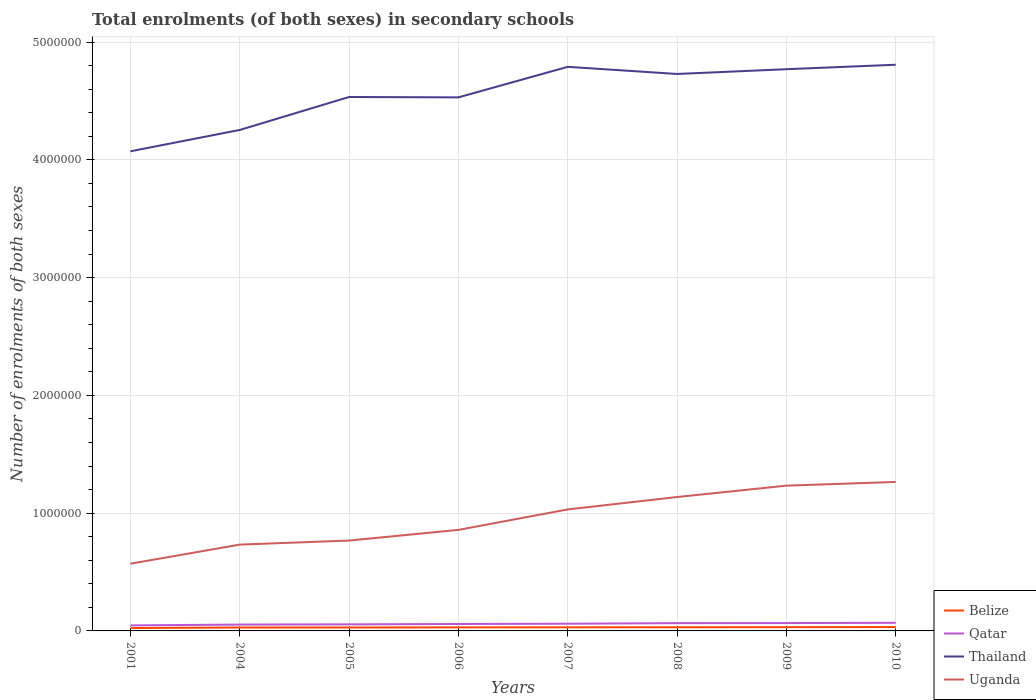Does the line corresponding to Uganda intersect with the line corresponding to Qatar?
Give a very brief answer. No. Is the number of lines equal to the number of legend labels?
Provide a short and direct response. Yes. Across all years, what is the maximum number of enrolments in secondary schools in Qatar?
Keep it short and to the point. 4.69e+04. In which year was the number of enrolments in secondary schools in Uganda maximum?
Your response must be concise. 2001. What is the total number of enrolments in secondary schools in Uganda in the graph?
Make the answer very short. -4.98e+05. What is the difference between the highest and the second highest number of enrolments in secondary schools in Belize?
Provide a short and direct response. 8385. What is the difference between the highest and the lowest number of enrolments in secondary schools in Uganda?
Your answer should be compact. 4. Is the number of enrolments in secondary schools in Belize strictly greater than the number of enrolments in secondary schools in Qatar over the years?
Provide a succinct answer. Yes. How many lines are there?
Keep it short and to the point. 4. How many legend labels are there?
Give a very brief answer. 4. How are the legend labels stacked?
Provide a short and direct response. Vertical. What is the title of the graph?
Give a very brief answer. Total enrolments (of both sexes) in secondary schools. Does "Serbia" appear as one of the legend labels in the graph?
Offer a terse response. No. What is the label or title of the Y-axis?
Ensure brevity in your answer.  Number of enrolments of both sexes. What is the Number of enrolments of both sexes in Belize in 2001?
Make the answer very short. 2.44e+04. What is the Number of enrolments of both sexes in Qatar in 2001?
Offer a terse response. 4.69e+04. What is the Number of enrolments of both sexes of Thailand in 2001?
Offer a very short reply. 4.07e+06. What is the Number of enrolments of both sexes of Uganda in 2001?
Make the answer very short. 5.71e+05. What is the Number of enrolments of both sexes in Belize in 2004?
Keep it short and to the point. 2.91e+04. What is the Number of enrolments of both sexes in Qatar in 2004?
Your answer should be very brief. 5.40e+04. What is the Number of enrolments of both sexes of Thailand in 2004?
Provide a short and direct response. 4.25e+06. What is the Number of enrolments of both sexes in Uganda in 2004?
Your answer should be very brief. 7.33e+05. What is the Number of enrolments of both sexes in Belize in 2005?
Make the answer very short. 2.92e+04. What is the Number of enrolments of both sexes in Qatar in 2005?
Ensure brevity in your answer.  5.57e+04. What is the Number of enrolments of both sexes in Thailand in 2005?
Your response must be concise. 4.53e+06. What is the Number of enrolments of both sexes of Uganda in 2005?
Offer a very short reply. 7.67e+05. What is the Number of enrolments of both sexes in Belize in 2006?
Ensure brevity in your answer.  3.01e+04. What is the Number of enrolments of both sexes in Qatar in 2006?
Offer a terse response. 5.88e+04. What is the Number of enrolments of both sexes in Thailand in 2006?
Your answer should be very brief. 4.53e+06. What is the Number of enrolments of both sexes of Uganda in 2006?
Ensure brevity in your answer.  8.58e+05. What is the Number of enrolments of both sexes in Belize in 2007?
Offer a very short reply. 3.05e+04. What is the Number of enrolments of both sexes in Qatar in 2007?
Provide a short and direct response. 6.11e+04. What is the Number of enrolments of both sexes of Thailand in 2007?
Make the answer very short. 4.79e+06. What is the Number of enrolments of both sexes of Uganda in 2007?
Offer a terse response. 1.03e+06. What is the Number of enrolments of both sexes in Belize in 2008?
Ensure brevity in your answer.  3.11e+04. What is the Number of enrolments of both sexes of Qatar in 2008?
Keep it short and to the point. 6.61e+04. What is the Number of enrolments of both sexes in Thailand in 2008?
Provide a succinct answer. 4.73e+06. What is the Number of enrolments of both sexes of Uganda in 2008?
Your answer should be very brief. 1.14e+06. What is the Number of enrolments of both sexes in Belize in 2009?
Offer a terse response. 3.17e+04. What is the Number of enrolments of both sexes of Qatar in 2009?
Your answer should be compact. 6.66e+04. What is the Number of enrolments of both sexes of Thailand in 2009?
Keep it short and to the point. 4.77e+06. What is the Number of enrolments of both sexes in Uganda in 2009?
Offer a very short reply. 1.23e+06. What is the Number of enrolments of both sexes in Belize in 2010?
Make the answer very short. 3.28e+04. What is the Number of enrolments of both sexes of Qatar in 2010?
Give a very brief answer. 6.89e+04. What is the Number of enrolments of both sexes in Thailand in 2010?
Your answer should be compact. 4.81e+06. What is the Number of enrolments of both sexes in Uganda in 2010?
Provide a succinct answer. 1.26e+06. Across all years, what is the maximum Number of enrolments of both sexes of Belize?
Provide a short and direct response. 3.28e+04. Across all years, what is the maximum Number of enrolments of both sexes in Qatar?
Your answer should be compact. 6.89e+04. Across all years, what is the maximum Number of enrolments of both sexes of Thailand?
Your answer should be compact. 4.81e+06. Across all years, what is the maximum Number of enrolments of both sexes in Uganda?
Your answer should be very brief. 1.26e+06. Across all years, what is the minimum Number of enrolments of both sexes of Belize?
Your answer should be compact. 2.44e+04. Across all years, what is the minimum Number of enrolments of both sexes in Qatar?
Your response must be concise. 4.69e+04. Across all years, what is the minimum Number of enrolments of both sexes in Thailand?
Offer a very short reply. 4.07e+06. Across all years, what is the minimum Number of enrolments of both sexes of Uganda?
Make the answer very short. 5.71e+05. What is the total Number of enrolments of both sexes in Belize in the graph?
Keep it short and to the point. 2.39e+05. What is the total Number of enrolments of both sexes of Qatar in the graph?
Keep it short and to the point. 4.78e+05. What is the total Number of enrolments of both sexes in Thailand in the graph?
Offer a terse response. 3.65e+07. What is the total Number of enrolments of both sexes in Uganda in the graph?
Keep it short and to the point. 7.60e+06. What is the difference between the Number of enrolments of both sexes of Belize in 2001 and that in 2004?
Your answer should be very brief. -4687. What is the difference between the Number of enrolments of both sexes in Qatar in 2001 and that in 2004?
Give a very brief answer. -7022. What is the difference between the Number of enrolments of both sexes of Thailand in 2001 and that in 2004?
Make the answer very short. -1.81e+05. What is the difference between the Number of enrolments of both sexes in Uganda in 2001 and that in 2004?
Ensure brevity in your answer.  -1.62e+05. What is the difference between the Number of enrolments of both sexes in Belize in 2001 and that in 2005?
Provide a succinct answer. -4790. What is the difference between the Number of enrolments of both sexes of Qatar in 2001 and that in 2005?
Your response must be concise. -8774. What is the difference between the Number of enrolments of both sexes of Thailand in 2001 and that in 2005?
Your answer should be compact. -4.61e+05. What is the difference between the Number of enrolments of both sexes in Uganda in 2001 and that in 2005?
Provide a succinct answer. -1.97e+05. What is the difference between the Number of enrolments of both sexes of Belize in 2001 and that in 2006?
Offer a terse response. -5689. What is the difference between the Number of enrolments of both sexes of Qatar in 2001 and that in 2006?
Keep it short and to the point. -1.19e+04. What is the difference between the Number of enrolments of both sexes of Thailand in 2001 and that in 2006?
Keep it short and to the point. -4.58e+05. What is the difference between the Number of enrolments of both sexes of Uganda in 2001 and that in 2006?
Ensure brevity in your answer.  -2.87e+05. What is the difference between the Number of enrolments of both sexes in Belize in 2001 and that in 2007?
Your answer should be compact. -6080. What is the difference between the Number of enrolments of both sexes of Qatar in 2001 and that in 2007?
Ensure brevity in your answer.  -1.42e+04. What is the difference between the Number of enrolments of both sexes in Thailand in 2001 and that in 2007?
Offer a very short reply. -7.17e+05. What is the difference between the Number of enrolments of both sexes of Uganda in 2001 and that in 2007?
Offer a very short reply. -4.61e+05. What is the difference between the Number of enrolments of both sexes of Belize in 2001 and that in 2008?
Provide a succinct answer. -6725. What is the difference between the Number of enrolments of both sexes in Qatar in 2001 and that in 2008?
Provide a succinct answer. -1.92e+04. What is the difference between the Number of enrolments of both sexes of Thailand in 2001 and that in 2008?
Provide a short and direct response. -6.57e+05. What is the difference between the Number of enrolments of both sexes in Uganda in 2001 and that in 2008?
Ensure brevity in your answer.  -5.66e+05. What is the difference between the Number of enrolments of both sexes in Belize in 2001 and that in 2009?
Give a very brief answer. -7326. What is the difference between the Number of enrolments of both sexes in Qatar in 2001 and that in 2009?
Your answer should be very brief. -1.97e+04. What is the difference between the Number of enrolments of both sexes of Thailand in 2001 and that in 2009?
Your answer should be very brief. -6.97e+05. What is the difference between the Number of enrolments of both sexes of Uganda in 2001 and that in 2009?
Your answer should be compact. -6.63e+05. What is the difference between the Number of enrolments of both sexes in Belize in 2001 and that in 2010?
Ensure brevity in your answer.  -8385. What is the difference between the Number of enrolments of both sexes of Qatar in 2001 and that in 2010?
Your answer should be very brief. -2.20e+04. What is the difference between the Number of enrolments of both sexes in Thailand in 2001 and that in 2010?
Your answer should be very brief. -7.35e+05. What is the difference between the Number of enrolments of both sexes of Uganda in 2001 and that in 2010?
Offer a terse response. -6.94e+05. What is the difference between the Number of enrolments of both sexes in Belize in 2004 and that in 2005?
Your answer should be very brief. -103. What is the difference between the Number of enrolments of both sexes of Qatar in 2004 and that in 2005?
Offer a terse response. -1752. What is the difference between the Number of enrolments of both sexes in Thailand in 2004 and that in 2005?
Offer a very short reply. -2.80e+05. What is the difference between the Number of enrolments of both sexes of Uganda in 2004 and that in 2005?
Your answer should be compact. -3.45e+04. What is the difference between the Number of enrolments of both sexes of Belize in 2004 and that in 2006?
Your answer should be compact. -1002. What is the difference between the Number of enrolments of both sexes in Qatar in 2004 and that in 2006?
Make the answer very short. -4834. What is the difference between the Number of enrolments of both sexes of Thailand in 2004 and that in 2006?
Your response must be concise. -2.77e+05. What is the difference between the Number of enrolments of both sexes in Uganda in 2004 and that in 2006?
Give a very brief answer. -1.25e+05. What is the difference between the Number of enrolments of both sexes in Belize in 2004 and that in 2007?
Give a very brief answer. -1393. What is the difference between the Number of enrolments of both sexes of Qatar in 2004 and that in 2007?
Give a very brief answer. -7157. What is the difference between the Number of enrolments of both sexes of Thailand in 2004 and that in 2007?
Your answer should be compact. -5.36e+05. What is the difference between the Number of enrolments of both sexes in Uganda in 2004 and that in 2007?
Offer a very short reply. -2.99e+05. What is the difference between the Number of enrolments of both sexes of Belize in 2004 and that in 2008?
Your answer should be compact. -2038. What is the difference between the Number of enrolments of both sexes in Qatar in 2004 and that in 2008?
Give a very brief answer. -1.21e+04. What is the difference between the Number of enrolments of both sexes of Thailand in 2004 and that in 2008?
Your answer should be compact. -4.75e+05. What is the difference between the Number of enrolments of both sexes of Uganda in 2004 and that in 2008?
Provide a succinct answer. -4.04e+05. What is the difference between the Number of enrolments of both sexes of Belize in 2004 and that in 2009?
Give a very brief answer. -2639. What is the difference between the Number of enrolments of both sexes of Qatar in 2004 and that in 2009?
Provide a short and direct response. -1.26e+04. What is the difference between the Number of enrolments of both sexes in Thailand in 2004 and that in 2009?
Offer a terse response. -5.16e+05. What is the difference between the Number of enrolments of both sexes of Uganda in 2004 and that in 2009?
Provide a succinct answer. -5.01e+05. What is the difference between the Number of enrolments of both sexes of Belize in 2004 and that in 2010?
Offer a very short reply. -3698. What is the difference between the Number of enrolments of both sexes in Qatar in 2004 and that in 2010?
Ensure brevity in your answer.  -1.50e+04. What is the difference between the Number of enrolments of both sexes of Thailand in 2004 and that in 2010?
Make the answer very short. -5.54e+05. What is the difference between the Number of enrolments of both sexes in Uganda in 2004 and that in 2010?
Your response must be concise. -5.32e+05. What is the difference between the Number of enrolments of both sexes of Belize in 2005 and that in 2006?
Your response must be concise. -899. What is the difference between the Number of enrolments of both sexes in Qatar in 2005 and that in 2006?
Provide a succinct answer. -3082. What is the difference between the Number of enrolments of both sexes in Thailand in 2005 and that in 2006?
Provide a succinct answer. 3144. What is the difference between the Number of enrolments of both sexes of Uganda in 2005 and that in 2006?
Provide a short and direct response. -9.05e+04. What is the difference between the Number of enrolments of both sexes in Belize in 2005 and that in 2007?
Offer a terse response. -1290. What is the difference between the Number of enrolments of both sexes in Qatar in 2005 and that in 2007?
Provide a short and direct response. -5405. What is the difference between the Number of enrolments of both sexes of Thailand in 2005 and that in 2007?
Your response must be concise. -2.56e+05. What is the difference between the Number of enrolments of both sexes of Uganda in 2005 and that in 2007?
Provide a short and direct response. -2.64e+05. What is the difference between the Number of enrolments of both sexes of Belize in 2005 and that in 2008?
Your response must be concise. -1935. What is the difference between the Number of enrolments of both sexes in Qatar in 2005 and that in 2008?
Your response must be concise. -1.04e+04. What is the difference between the Number of enrolments of both sexes in Thailand in 2005 and that in 2008?
Keep it short and to the point. -1.96e+05. What is the difference between the Number of enrolments of both sexes of Uganda in 2005 and that in 2008?
Your response must be concise. -3.70e+05. What is the difference between the Number of enrolments of both sexes in Belize in 2005 and that in 2009?
Provide a succinct answer. -2536. What is the difference between the Number of enrolments of both sexes in Qatar in 2005 and that in 2009?
Make the answer very short. -1.09e+04. What is the difference between the Number of enrolments of both sexes of Thailand in 2005 and that in 2009?
Keep it short and to the point. -2.36e+05. What is the difference between the Number of enrolments of both sexes of Uganda in 2005 and that in 2009?
Your answer should be compact. -4.66e+05. What is the difference between the Number of enrolments of both sexes of Belize in 2005 and that in 2010?
Your response must be concise. -3595. What is the difference between the Number of enrolments of both sexes of Qatar in 2005 and that in 2010?
Offer a terse response. -1.32e+04. What is the difference between the Number of enrolments of both sexes in Thailand in 2005 and that in 2010?
Provide a short and direct response. -2.74e+05. What is the difference between the Number of enrolments of both sexes in Uganda in 2005 and that in 2010?
Your response must be concise. -4.98e+05. What is the difference between the Number of enrolments of both sexes of Belize in 2006 and that in 2007?
Provide a short and direct response. -391. What is the difference between the Number of enrolments of both sexes of Qatar in 2006 and that in 2007?
Provide a short and direct response. -2323. What is the difference between the Number of enrolments of both sexes of Thailand in 2006 and that in 2007?
Offer a very short reply. -2.59e+05. What is the difference between the Number of enrolments of both sexes in Uganda in 2006 and that in 2007?
Provide a short and direct response. -1.74e+05. What is the difference between the Number of enrolments of both sexes in Belize in 2006 and that in 2008?
Provide a succinct answer. -1036. What is the difference between the Number of enrolments of both sexes in Qatar in 2006 and that in 2008?
Your response must be concise. -7297. What is the difference between the Number of enrolments of both sexes in Thailand in 2006 and that in 2008?
Offer a terse response. -1.99e+05. What is the difference between the Number of enrolments of both sexes in Uganda in 2006 and that in 2008?
Give a very brief answer. -2.79e+05. What is the difference between the Number of enrolments of both sexes in Belize in 2006 and that in 2009?
Make the answer very short. -1637. What is the difference between the Number of enrolments of both sexes in Qatar in 2006 and that in 2009?
Give a very brief answer. -7797. What is the difference between the Number of enrolments of both sexes of Thailand in 2006 and that in 2009?
Your response must be concise. -2.39e+05. What is the difference between the Number of enrolments of both sexes of Uganda in 2006 and that in 2009?
Keep it short and to the point. -3.76e+05. What is the difference between the Number of enrolments of both sexes of Belize in 2006 and that in 2010?
Your response must be concise. -2696. What is the difference between the Number of enrolments of both sexes of Qatar in 2006 and that in 2010?
Give a very brief answer. -1.01e+04. What is the difference between the Number of enrolments of both sexes in Thailand in 2006 and that in 2010?
Keep it short and to the point. -2.77e+05. What is the difference between the Number of enrolments of both sexes in Uganda in 2006 and that in 2010?
Your answer should be very brief. -4.07e+05. What is the difference between the Number of enrolments of both sexes in Belize in 2007 and that in 2008?
Give a very brief answer. -645. What is the difference between the Number of enrolments of both sexes of Qatar in 2007 and that in 2008?
Provide a succinct answer. -4974. What is the difference between the Number of enrolments of both sexes in Thailand in 2007 and that in 2008?
Your response must be concise. 6.06e+04. What is the difference between the Number of enrolments of both sexes of Uganda in 2007 and that in 2008?
Provide a succinct answer. -1.05e+05. What is the difference between the Number of enrolments of both sexes of Belize in 2007 and that in 2009?
Make the answer very short. -1246. What is the difference between the Number of enrolments of both sexes of Qatar in 2007 and that in 2009?
Keep it short and to the point. -5474. What is the difference between the Number of enrolments of both sexes of Thailand in 2007 and that in 2009?
Your response must be concise. 2.01e+04. What is the difference between the Number of enrolments of both sexes of Uganda in 2007 and that in 2009?
Your response must be concise. -2.02e+05. What is the difference between the Number of enrolments of both sexes of Belize in 2007 and that in 2010?
Your answer should be very brief. -2305. What is the difference between the Number of enrolments of both sexes of Qatar in 2007 and that in 2010?
Provide a short and direct response. -7814. What is the difference between the Number of enrolments of both sexes in Thailand in 2007 and that in 2010?
Offer a terse response. -1.78e+04. What is the difference between the Number of enrolments of both sexes of Uganda in 2007 and that in 2010?
Ensure brevity in your answer.  -2.33e+05. What is the difference between the Number of enrolments of both sexes of Belize in 2008 and that in 2009?
Provide a short and direct response. -601. What is the difference between the Number of enrolments of both sexes of Qatar in 2008 and that in 2009?
Ensure brevity in your answer.  -500. What is the difference between the Number of enrolments of both sexes in Thailand in 2008 and that in 2009?
Provide a succinct answer. -4.04e+04. What is the difference between the Number of enrolments of both sexes in Uganda in 2008 and that in 2009?
Offer a terse response. -9.66e+04. What is the difference between the Number of enrolments of both sexes of Belize in 2008 and that in 2010?
Offer a terse response. -1660. What is the difference between the Number of enrolments of both sexes in Qatar in 2008 and that in 2010?
Provide a succinct answer. -2840. What is the difference between the Number of enrolments of both sexes of Thailand in 2008 and that in 2010?
Make the answer very short. -7.83e+04. What is the difference between the Number of enrolments of both sexes of Uganda in 2008 and that in 2010?
Give a very brief answer. -1.28e+05. What is the difference between the Number of enrolments of both sexes in Belize in 2009 and that in 2010?
Offer a very short reply. -1059. What is the difference between the Number of enrolments of both sexes of Qatar in 2009 and that in 2010?
Provide a succinct answer. -2340. What is the difference between the Number of enrolments of both sexes in Thailand in 2009 and that in 2010?
Provide a short and direct response. -3.79e+04. What is the difference between the Number of enrolments of both sexes in Uganda in 2009 and that in 2010?
Make the answer very short. -3.16e+04. What is the difference between the Number of enrolments of both sexes in Belize in 2001 and the Number of enrolments of both sexes in Qatar in 2004?
Provide a short and direct response. -2.96e+04. What is the difference between the Number of enrolments of both sexes of Belize in 2001 and the Number of enrolments of both sexes of Thailand in 2004?
Provide a succinct answer. -4.23e+06. What is the difference between the Number of enrolments of both sexes in Belize in 2001 and the Number of enrolments of both sexes in Uganda in 2004?
Provide a short and direct response. -7.08e+05. What is the difference between the Number of enrolments of both sexes in Qatar in 2001 and the Number of enrolments of both sexes in Thailand in 2004?
Your response must be concise. -4.21e+06. What is the difference between the Number of enrolments of both sexes of Qatar in 2001 and the Number of enrolments of both sexes of Uganda in 2004?
Give a very brief answer. -6.86e+05. What is the difference between the Number of enrolments of both sexes in Thailand in 2001 and the Number of enrolments of both sexes in Uganda in 2004?
Your answer should be very brief. 3.34e+06. What is the difference between the Number of enrolments of both sexes in Belize in 2001 and the Number of enrolments of both sexes in Qatar in 2005?
Give a very brief answer. -3.13e+04. What is the difference between the Number of enrolments of both sexes of Belize in 2001 and the Number of enrolments of both sexes of Thailand in 2005?
Provide a short and direct response. -4.51e+06. What is the difference between the Number of enrolments of both sexes of Belize in 2001 and the Number of enrolments of both sexes of Uganda in 2005?
Your answer should be compact. -7.43e+05. What is the difference between the Number of enrolments of both sexes of Qatar in 2001 and the Number of enrolments of both sexes of Thailand in 2005?
Ensure brevity in your answer.  -4.49e+06. What is the difference between the Number of enrolments of both sexes in Qatar in 2001 and the Number of enrolments of both sexes in Uganda in 2005?
Provide a short and direct response. -7.20e+05. What is the difference between the Number of enrolments of both sexes of Thailand in 2001 and the Number of enrolments of both sexes of Uganda in 2005?
Provide a succinct answer. 3.30e+06. What is the difference between the Number of enrolments of both sexes in Belize in 2001 and the Number of enrolments of both sexes in Qatar in 2006?
Your answer should be compact. -3.44e+04. What is the difference between the Number of enrolments of both sexes of Belize in 2001 and the Number of enrolments of both sexes of Thailand in 2006?
Keep it short and to the point. -4.51e+06. What is the difference between the Number of enrolments of both sexes of Belize in 2001 and the Number of enrolments of both sexes of Uganda in 2006?
Give a very brief answer. -8.33e+05. What is the difference between the Number of enrolments of both sexes of Qatar in 2001 and the Number of enrolments of both sexes of Thailand in 2006?
Make the answer very short. -4.48e+06. What is the difference between the Number of enrolments of both sexes in Qatar in 2001 and the Number of enrolments of both sexes in Uganda in 2006?
Provide a short and direct response. -8.11e+05. What is the difference between the Number of enrolments of both sexes in Thailand in 2001 and the Number of enrolments of both sexes in Uganda in 2006?
Offer a terse response. 3.21e+06. What is the difference between the Number of enrolments of both sexes of Belize in 2001 and the Number of enrolments of both sexes of Qatar in 2007?
Keep it short and to the point. -3.67e+04. What is the difference between the Number of enrolments of both sexes of Belize in 2001 and the Number of enrolments of both sexes of Thailand in 2007?
Provide a succinct answer. -4.76e+06. What is the difference between the Number of enrolments of both sexes in Belize in 2001 and the Number of enrolments of both sexes in Uganda in 2007?
Give a very brief answer. -1.01e+06. What is the difference between the Number of enrolments of both sexes in Qatar in 2001 and the Number of enrolments of both sexes in Thailand in 2007?
Offer a terse response. -4.74e+06. What is the difference between the Number of enrolments of both sexes in Qatar in 2001 and the Number of enrolments of both sexes in Uganda in 2007?
Keep it short and to the point. -9.85e+05. What is the difference between the Number of enrolments of both sexes in Thailand in 2001 and the Number of enrolments of both sexes in Uganda in 2007?
Keep it short and to the point. 3.04e+06. What is the difference between the Number of enrolments of both sexes of Belize in 2001 and the Number of enrolments of both sexes of Qatar in 2008?
Offer a terse response. -4.17e+04. What is the difference between the Number of enrolments of both sexes in Belize in 2001 and the Number of enrolments of both sexes in Thailand in 2008?
Give a very brief answer. -4.70e+06. What is the difference between the Number of enrolments of both sexes of Belize in 2001 and the Number of enrolments of both sexes of Uganda in 2008?
Your answer should be compact. -1.11e+06. What is the difference between the Number of enrolments of both sexes in Qatar in 2001 and the Number of enrolments of both sexes in Thailand in 2008?
Offer a very short reply. -4.68e+06. What is the difference between the Number of enrolments of both sexes in Qatar in 2001 and the Number of enrolments of both sexes in Uganda in 2008?
Ensure brevity in your answer.  -1.09e+06. What is the difference between the Number of enrolments of both sexes of Thailand in 2001 and the Number of enrolments of both sexes of Uganda in 2008?
Provide a short and direct response. 2.94e+06. What is the difference between the Number of enrolments of both sexes of Belize in 2001 and the Number of enrolments of both sexes of Qatar in 2009?
Offer a terse response. -4.22e+04. What is the difference between the Number of enrolments of both sexes of Belize in 2001 and the Number of enrolments of both sexes of Thailand in 2009?
Give a very brief answer. -4.74e+06. What is the difference between the Number of enrolments of both sexes in Belize in 2001 and the Number of enrolments of both sexes in Uganda in 2009?
Give a very brief answer. -1.21e+06. What is the difference between the Number of enrolments of both sexes in Qatar in 2001 and the Number of enrolments of both sexes in Thailand in 2009?
Your answer should be very brief. -4.72e+06. What is the difference between the Number of enrolments of both sexes in Qatar in 2001 and the Number of enrolments of both sexes in Uganda in 2009?
Your response must be concise. -1.19e+06. What is the difference between the Number of enrolments of both sexes of Thailand in 2001 and the Number of enrolments of both sexes of Uganda in 2009?
Offer a very short reply. 2.84e+06. What is the difference between the Number of enrolments of both sexes in Belize in 2001 and the Number of enrolments of both sexes in Qatar in 2010?
Provide a short and direct response. -4.45e+04. What is the difference between the Number of enrolments of both sexes of Belize in 2001 and the Number of enrolments of both sexes of Thailand in 2010?
Give a very brief answer. -4.78e+06. What is the difference between the Number of enrolments of both sexes in Belize in 2001 and the Number of enrolments of both sexes in Uganda in 2010?
Make the answer very short. -1.24e+06. What is the difference between the Number of enrolments of both sexes of Qatar in 2001 and the Number of enrolments of both sexes of Thailand in 2010?
Make the answer very short. -4.76e+06. What is the difference between the Number of enrolments of both sexes of Qatar in 2001 and the Number of enrolments of both sexes of Uganda in 2010?
Keep it short and to the point. -1.22e+06. What is the difference between the Number of enrolments of both sexes in Thailand in 2001 and the Number of enrolments of both sexes in Uganda in 2010?
Offer a very short reply. 2.81e+06. What is the difference between the Number of enrolments of both sexes of Belize in 2004 and the Number of enrolments of both sexes of Qatar in 2005?
Keep it short and to the point. -2.66e+04. What is the difference between the Number of enrolments of both sexes in Belize in 2004 and the Number of enrolments of both sexes in Thailand in 2005?
Make the answer very short. -4.50e+06. What is the difference between the Number of enrolments of both sexes of Belize in 2004 and the Number of enrolments of both sexes of Uganda in 2005?
Make the answer very short. -7.38e+05. What is the difference between the Number of enrolments of both sexes of Qatar in 2004 and the Number of enrolments of both sexes of Thailand in 2005?
Give a very brief answer. -4.48e+06. What is the difference between the Number of enrolments of both sexes in Qatar in 2004 and the Number of enrolments of both sexes in Uganda in 2005?
Keep it short and to the point. -7.13e+05. What is the difference between the Number of enrolments of both sexes of Thailand in 2004 and the Number of enrolments of both sexes of Uganda in 2005?
Your answer should be very brief. 3.49e+06. What is the difference between the Number of enrolments of both sexes of Belize in 2004 and the Number of enrolments of both sexes of Qatar in 2006?
Your answer should be compact. -2.97e+04. What is the difference between the Number of enrolments of both sexes of Belize in 2004 and the Number of enrolments of both sexes of Thailand in 2006?
Provide a succinct answer. -4.50e+06. What is the difference between the Number of enrolments of both sexes of Belize in 2004 and the Number of enrolments of both sexes of Uganda in 2006?
Make the answer very short. -8.29e+05. What is the difference between the Number of enrolments of both sexes in Qatar in 2004 and the Number of enrolments of both sexes in Thailand in 2006?
Keep it short and to the point. -4.48e+06. What is the difference between the Number of enrolments of both sexes in Qatar in 2004 and the Number of enrolments of both sexes in Uganda in 2006?
Your answer should be very brief. -8.04e+05. What is the difference between the Number of enrolments of both sexes of Thailand in 2004 and the Number of enrolments of both sexes of Uganda in 2006?
Provide a short and direct response. 3.40e+06. What is the difference between the Number of enrolments of both sexes of Belize in 2004 and the Number of enrolments of both sexes of Qatar in 2007?
Provide a short and direct response. -3.20e+04. What is the difference between the Number of enrolments of both sexes of Belize in 2004 and the Number of enrolments of both sexes of Thailand in 2007?
Keep it short and to the point. -4.76e+06. What is the difference between the Number of enrolments of both sexes of Belize in 2004 and the Number of enrolments of both sexes of Uganda in 2007?
Your response must be concise. -1.00e+06. What is the difference between the Number of enrolments of both sexes in Qatar in 2004 and the Number of enrolments of both sexes in Thailand in 2007?
Provide a succinct answer. -4.74e+06. What is the difference between the Number of enrolments of both sexes of Qatar in 2004 and the Number of enrolments of both sexes of Uganda in 2007?
Your answer should be compact. -9.78e+05. What is the difference between the Number of enrolments of both sexes in Thailand in 2004 and the Number of enrolments of both sexes in Uganda in 2007?
Your response must be concise. 3.22e+06. What is the difference between the Number of enrolments of both sexes of Belize in 2004 and the Number of enrolments of both sexes of Qatar in 2008?
Provide a succinct answer. -3.70e+04. What is the difference between the Number of enrolments of both sexes of Belize in 2004 and the Number of enrolments of both sexes of Thailand in 2008?
Ensure brevity in your answer.  -4.70e+06. What is the difference between the Number of enrolments of both sexes in Belize in 2004 and the Number of enrolments of both sexes in Uganda in 2008?
Provide a short and direct response. -1.11e+06. What is the difference between the Number of enrolments of both sexes of Qatar in 2004 and the Number of enrolments of both sexes of Thailand in 2008?
Your answer should be very brief. -4.67e+06. What is the difference between the Number of enrolments of both sexes of Qatar in 2004 and the Number of enrolments of both sexes of Uganda in 2008?
Ensure brevity in your answer.  -1.08e+06. What is the difference between the Number of enrolments of both sexes of Thailand in 2004 and the Number of enrolments of both sexes of Uganda in 2008?
Ensure brevity in your answer.  3.12e+06. What is the difference between the Number of enrolments of both sexes in Belize in 2004 and the Number of enrolments of both sexes in Qatar in 2009?
Make the answer very short. -3.75e+04. What is the difference between the Number of enrolments of both sexes of Belize in 2004 and the Number of enrolments of both sexes of Thailand in 2009?
Your response must be concise. -4.74e+06. What is the difference between the Number of enrolments of both sexes in Belize in 2004 and the Number of enrolments of both sexes in Uganda in 2009?
Keep it short and to the point. -1.20e+06. What is the difference between the Number of enrolments of both sexes in Qatar in 2004 and the Number of enrolments of both sexes in Thailand in 2009?
Provide a succinct answer. -4.72e+06. What is the difference between the Number of enrolments of both sexes of Qatar in 2004 and the Number of enrolments of both sexes of Uganda in 2009?
Your answer should be compact. -1.18e+06. What is the difference between the Number of enrolments of both sexes of Thailand in 2004 and the Number of enrolments of both sexes of Uganda in 2009?
Keep it short and to the point. 3.02e+06. What is the difference between the Number of enrolments of both sexes of Belize in 2004 and the Number of enrolments of both sexes of Qatar in 2010?
Offer a very short reply. -3.98e+04. What is the difference between the Number of enrolments of both sexes of Belize in 2004 and the Number of enrolments of both sexes of Thailand in 2010?
Ensure brevity in your answer.  -4.78e+06. What is the difference between the Number of enrolments of both sexes in Belize in 2004 and the Number of enrolments of both sexes in Uganda in 2010?
Ensure brevity in your answer.  -1.24e+06. What is the difference between the Number of enrolments of both sexes in Qatar in 2004 and the Number of enrolments of both sexes in Thailand in 2010?
Keep it short and to the point. -4.75e+06. What is the difference between the Number of enrolments of both sexes of Qatar in 2004 and the Number of enrolments of both sexes of Uganda in 2010?
Provide a short and direct response. -1.21e+06. What is the difference between the Number of enrolments of both sexes of Thailand in 2004 and the Number of enrolments of both sexes of Uganda in 2010?
Keep it short and to the point. 2.99e+06. What is the difference between the Number of enrolments of both sexes in Belize in 2005 and the Number of enrolments of both sexes in Qatar in 2006?
Your response must be concise. -2.96e+04. What is the difference between the Number of enrolments of both sexes in Belize in 2005 and the Number of enrolments of both sexes in Thailand in 2006?
Provide a succinct answer. -4.50e+06. What is the difference between the Number of enrolments of both sexes of Belize in 2005 and the Number of enrolments of both sexes of Uganda in 2006?
Make the answer very short. -8.29e+05. What is the difference between the Number of enrolments of both sexes in Qatar in 2005 and the Number of enrolments of both sexes in Thailand in 2006?
Provide a short and direct response. -4.47e+06. What is the difference between the Number of enrolments of both sexes of Qatar in 2005 and the Number of enrolments of both sexes of Uganda in 2006?
Your answer should be very brief. -8.02e+05. What is the difference between the Number of enrolments of both sexes in Thailand in 2005 and the Number of enrolments of both sexes in Uganda in 2006?
Ensure brevity in your answer.  3.68e+06. What is the difference between the Number of enrolments of both sexes in Belize in 2005 and the Number of enrolments of both sexes in Qatar in 2007?
Your response must be concise. -3.19e+04. What is the difference between the Number of enrolments of both sexes of Belize in 2005 and the Number of enrolments of both sexes of Thailand in 2007?
Make the answer very short. -4.76e+06. What is the difference between the Number of enrolments of both sexes of Belize in 2005 and the Number of enrolments of both sexes of Uganda in 2007?
Ensure brevity in your answer.  -1.00e+06. What is the difference between the Number of enrolments of both sexes of Qatar in 2005 and the Number of enrolments of both sexes of Thailand in 2007?
Your answer should be compact. -4.73e+06. What is the difference between the Number of enrolments of both sexes of Qatar in 2005 and the Number of enrolments of both sexes of Uganda in 2007?
Provide a short and direct response. -9.76e+05. What is the difference between the Number of enrolments of both sexes of Thailand in 2005 and the Number of enrolments of both sexes of Uganda in 2007?
Your answer should be compact. 3.50e+06. What is the difference between the Number of enrolments of both sexes in Belize in 2005 and the Number of enrolments of both sexes in Qatar in 2008?
Keep it short and to the point. -3.69e+04. What is the difference between the Number of enrolments of both sexes of Belize in 2005 and the Number of enrolments of both sexes of Thailand in 2008?
Offer a very short reply. -4.70e+06. What is the difference between the Number of enrolments of both sexes of Belize in 2005 and the Number of enrolments of both sexes of Uganda in 2008?
Keep it short and to the point. -1.11e+06. What is the difference between the Number of enrolments of both sexes of Qatar in 2005 and the Number of enrolments of both sexes of Thailand in 2008?
Make the answer very short. -4.67e+06. What is the difference between the Number of enrolments of both sexes of Qatar in 2005 and the Number of enrolments of both sexes of Uganda in 2008?
Give a very brief answer. -1.08e+06. What is the difference between the Number of enrolments of both sexes in Thailand in 2005 and the Number of enrolments of both sexes in Uganda in 2008?
Your response must be concise. 3.40e+06. What is the difference between the Number of enrolments of both sexes in Belize in 2005 and the Number of enrolments of both sexes in Qatar in 2009?
Keep it short and to the point. -3.74e+04. What is the difference between the Number of enrolments of both sexes in Belize in 2005 and the Number of enrolments of both sexes in Thailand in 2009?
Your response must be concise. -4.74e+06. What is the difference between the Number of enrolments of both sexes of Belize in 2005 and the Number of enrolments of both sexes of Uganda in 2009?
Keep it short and to the point. -1.20e+06. What is the difference between the Number of enrolments of both sexes in Qatar in 2005 and the Number of enrolments of both sexes in Thailand in 2009?
Provide a short and direct response. -4.71e+06. What is the difference between the Number of enrolments of both sexes of Qatar in 2005 and the Number of enrolments of both sexes of Uganda in 2009?
Provide a succinct answer. -1.18e+06. What is the difference between the Number of enrolments of both sexes of Thailand in 2005 and the Number of enrolments of both sexes of Uganda in 2009?
Offer a terse response. 3.30e+06. What is the difference between the Number of enrolments of both sexes of Belize in 2005 and the Number of enrolments of both sexes of Qatar in 2010?
Offer a very short reply. -3.97e+04. What is the difference between the Number of enrolments of both sexes of Belize in 2005 and the Number of enrolments of both sexes of Thailand in 2010?
Keep it short and to the point. -4.78e+06. What is the difference between the Number of enrolments of both sexes in Belize in 2005 and the Number of enrolments of both sexes in Uganda in 2010?
Offer a terse response. -1.24e+06. What is the difference between the Number of enrolments of both sexes of Qatar in 2005 and the Number of enrolments of both sexes of Thailand in 2010?
Offer a very short reply. -4.75e+06. What is the difference between the Number of enrolments of both sexes of Qatar in 2005 and the Number of enrolments of both sexes of Uganda in 2010?
Make the answer very short. -1.21e+06. What is the difference between the Number of enrolments of both sexes of Thailand in 2005 and the Number of enrolments of both sexes of Uganda in 2010?
Provide a short and direct response. 3.27e+06. What is the difference between the Number of enrolments of both sexes of Belize in 2006 and the Number of enrolments of both sexes of Qatar in 2007?
Your answer should be compact. -3.10e+04. What is the difference between the Number of enrolments of both sexes of Belize in 2006 and the Number of enrolments of both sexes of Thailand in 2007?
Give a very brief answer. -4.76e+06. What is the difference between the Number of enrolments of both sexes in Belize in 2006 and the Number of enrolments of both sexes in Uganda in 2007?
Ensure brevity in your answer.  -1.00e+06. What is the difference between the Number of enrolments of both sexes in Qatar in 2006 and the Number of enrolments of both sexes in Thailand in 2007?
Provide a short and direct response. -4.73e+06. What is the difference between the Number of enrolments of both sexes in Qatar in 2006 and the Number of enrolments of both sexes in Uganda in 2007?
Ensure brevity in your answer.  -9.73e+05. What is the difference between the Number of enrolments of both sexes in Thailand in 2006 and the Number of enrolments of both sexes in Uganda in 2007?
Offer a very short reply. 3.50e+06. What is the difference between the Number of enrolments of both sexes of Belize in 2006 and the Number of enrolments of both sexes of Qatar in 2008?
Offer a very short reply. -3.60e+04. What is the difference between the Number of enrolments of both sexes in Belize in 2006 and the Number of enrolments of both sexes in Thailand in 2008?
Provide a short and direct response. -4.70e+06. What is the difference between the Number of enrolments of both sexes in Belize in 2006 and the Number of enrolments of both sexes in Uganda in 2008?
Ensure brevity in your answer.  -1.11e+06. What is the difference between the Number of enrolments of both sexes of Qatar in 2006 and the Number of enrolments of both sexes of Thailand in 2008?
Your response must be concise. -4.67e+06. What is the difference between the Number of enrolments of both sexes of Qatar in 2006 and the Number of enrolments of both sexes of Uganda in 2008?
Make the answer very short. -1.08e+06. What is the difference between the Number of enrolments of both sexes of Thailand in 2006 and the Number of enrolments of both sexes of Uganda in 2008?
Offer a terse response. 3.39e+06. What is the difference between the Number of enrolments of both sexes of Belize in 2006 and the Number of enrolments of both sexes of Qatar in 2009?
Offer a terse response. -3.65e+04. What is the difference between the Number of enrolments of both sexes in Belize in 2006 and the Number of enrolments of both sexes in Thailand in 2009?
Provide a succinct answer. -4.74e+06. What is the difference between the Number of enrolments of both sexes of Belize in 2006 and the Number of enrolments of both sexes of Uganda in 2009?
Offer a terse response. -1.20e+06. What is the difference between the Number of enrolments of both sexes in Qatar in 2006 and the Number of enrolments of both sexes in Thailand in 2009?
Provide a succinct answer. -4.71e+06. What is the difference between the Number of enrolments of both sexes in Qatar in 2006 and the Number of enrolments of both sexes in Uganda in 2009?
Offer a very short reply. -1.17e+06. What is the difference between the Number of enrolments of both sexes of Thailand in 2006 and the Number of enrolments of both sexes of Uganda in 2009?
Make the answer very short. 3.30e+06. What is the difference between the Number of enrolments of both sexes of Belize in 2006 and the Number of enrolments of both sexes of Qatar in 2010?
Your answer should be compact. -3.88e+04. What is the difference between the Number of enrolments of both sexes in Belize in 2006 and the Number of enrolments of both sexes in Thailand in 2010?
Ensure brevity in your answer.  -4.78e+06. What is the difference between the Number of enrolments of both sexes in Belize in 2006 and the Number of enrolments of both sexes in Uganda in 2010?
Give a very brief answer. -1.23e+06. What is the difference between the Number of enrolments of both sexes in Qatar in 2006 and the Number of enrolments of both sexes in Thailand in 2010?
Keep it short and to the point. -4.75e+06. What is the difference between the Number of enrolments of both sexes of Qatar in 2006 and the Number of enrolments of both sexes of Uganda in 2010?
Give a very brief answer. -1.21e+06. What is the difference between the Number of enrolments of both sexes in Thailand in 2006 and the Number of enrolments of both sexes in Uganda in 2010?
Make the answer very short. 3.27e+06. What is the difference between the Number of enrolments of both sexes of Belize in 2007 and the Number of enrolments of both sexes of Qatar in 2008?
Give a very brief answer. -3.56e+04. What is the difference between the Number of enrolments of both sexes of Belize in 2007 and the Number of enrolments of both sexes of Thailand in 2008?
Provide a succinct answer. -4.70e+06. What is the difference between the Number of enrolments of both sexes in Belize in 2007 and the Number of enrolments of both sexes in Uganda in 2008?
Make the answer very short. -1.11e+06. What is the difference between the Number of enrolments of both sexes of Qatar in 2007 and the Number of enrolments of both sexes of Thailand in 2008?
Offer a very short reply. -4.67e+06. What is the difference between the Number of enrolments of both sexes in Qatar in 2007 and the Number of enrolments of both sexes in Uganda in 2008?
Your answer should be very brief. -1.08e+06. What is the difference between the Number of enrolments of both sexes in Thailand in 2007 and the Number of enrolments of both sexes in Uganda in 2008?
Your answer should be compact. 3.65e+06. What is the difference between the Number of enrolments of both sexes of Belize in 2007 and the Number of enrolments of both sexes of Qatar in 2009?
Offer a terse response. -3.61e+04. What is the difference between the Number of enrolments of both sexes of Belize in 2007 and the Number of enrolments of both sexes of Thailand in 2009?
Your response must be concise. -4.74e+06. What is the difference between the Number of enrolments of both sexes in Belize in 2007 and the Number of enrolments of both sexes in Uganda in 2009?
Provide a succinct answer. -1.20e+06. What is the difference between the Number of enrolments of both sexes of Qatar in 2007 and the Number of enrolments of both sexes of Thailand in 2009?
Give a very brief answer. -4.71e+06. What is the difference between the Number of enrolments of both sexes of Qatar in 2007 and the Number of enrolments of both sexes of Uganda in 2009?
Ensure brevity in your answer.  -1.17e+06. What is the difference between the Number of enrolments of both sexes in Thailand in 2007 and the Number of enrolments of both sexes in Uganda in 2009?
Offer a very short reply. 3.56e+06. What is the difference between the Number of enrolments of both sexes of Belize in 2007 and the Number of enrolments of both sexes of Qatar in 2010?
Offer a terse response. -3.84e+04. What is the difference between the Number of enrolments of both sexes of Belize in 2007 and the Number of enrolments of both sexes of Thailand in 2010?
Keep it short and to the point. -4.78e+06. What is the difference between the Number of enrolments of both sexes in Belize in 2007 and the Number of enrolments of both sexes in Uganda in 2010?
Provide a short and direct response. -1.23e+06. What is the difference between the Number of enrolments of both sexes of Qatar in 2007 and the Number of enrolments of both sexes of Thailand in 2010?
Offer a terse response. -4.75e+06. What is the difference between the Number of enrolments of both sexes in Qatar in 2007 and the Number of enrolments of both sexes in Uganda in 2010?
Provide a short and direct response. -1.20e+06. What is the difference between the Number of enrolments of both sexes in Thailand in 2007 and the Number of enrolments of both sexes in Uganda in 2010?
Provide a succinct answer. 3.52e+06. What is the difference between the Number of enrolments of both sexes of Belize in 2008 and the Number of enrolments of both sexes of Qatar in 2009?
Provide a succinct answer. -3.55e+04. What is the difference between the Number of enrolments of both sexes of Belize in 2008 and the Number of enrolments of both sexes of Thailand in 2009?
Your answer should be compact. -4.74e+06. What is the difference between the Number of enrolments of both sexes of Belize in 2008 and the Number of enrolments of both sexes of Uganda in 2009?
Make the answer very short. -1.20e+06. What is the difference between the Number of enrolments of both sexes in Qatar in 2008 and the Number of enrolments of both sexes in Thailand in 2009?
Offer a very short reply. -4.70e+06. What is the difference between the Number of enrolments of both sexes in Qatar in 2008 and the Number of enrolments of both sexes in Uganda in 2009?
Provide a short and direct response. -1.17e+06. What is the difference between the Number of enrolments of both sexes in Thailand in 2008 and the Number of enrolments of both sexes in Uganda in 2009?
Offer a very short reply. 3.50e+06. What is the difference between the Number of enrolments of both sexes in Belize in 2008 and the Number of enrolments of both sexes in Qatar in 2010?
Make the answer very short. -3.78e+04. What is the difference between the Number of enrolments of both sexes in Belize in 2008 and the Number of enrolments of both sexes in Thailand in 2010?
Ensure brevity in your answer.  -4.78e+06. What is the difference between the Number of enrolments of both sexes in Belize in 2008 and the Number of enrolments of both sexes in Uganda in 2010?
Offer a very short reply. -1.23e+06. What is the difference between the Number of enrolments of both sexes in Qatar in 2008 and the Number of enrolments of both sexes in Thailand in 2010?
Provide a short and direct response. -4.74e+06. What is the difference between the Number of enrolments of both sexes of Qatar in 2008 and the Number of enrolments of both sexes of Uganda in 2010?
Keep it short and to the point. -1.20e+06. What is the difference between the Number of enrolments of both sexes in Thailand in 2008 and the Number of enrolments of both sexes in Uganda in 2010?
Make the answer very short. 3.46e+06. What is the difference between the Number of enrolments of both sexes in Belize in 2009 and the Number of enrolments of both sexes in Qatar in 2010?
Your response must be concise. -3.72e+04. What is the difference between the Number of enrolments of both sexes in Belize in 2009 and the Number of enrolments of both sexes in Thailand in 2010?
Your answer should be compact. -4.78e+06. What is the difference between the Number of enrolments of both sexes of Belize in 2009 and the Number of enrolments of both sexes of Uganda in 2010?
Provide a short and direct response. -1.23e+06. What is the difference between the Number of enrolments of both sexes of Qatar in 2009 and the Number of enrolments of both sexes of Thailand in 2010?
Your response must be concise. -4.74e+06. What is the difference between the Number of enrolments of both sexes in Qatar in 2009 and the Number of enrolments of both sexes in Uganda in 2010?
Give a very brief answer. -1.20e+06. What is the difference between the Number of enrolments of both sexes in Thailand in 2009 and the Number of enrolments of both sexes in Uganda in 2010?
Offer a terse response. 3.50e+06. What is the average Number of enrolments of both sexes of Belize per year?
Offer a very short reply. 2.99e+04. What is the average Number of enrolments of both sexes in Qatar per year?
Make the answer very short. 5.98e+04. What is the average Number of enrolments of both sexes in Thailand per year?
Ensure brevity in your answer.  4.56e+06. What is the average Number of enrolments of both sexes in Uganda per year?
Ensure brevity in your answer.  9.49e+05. In the year 2001, what is the difference between the Number of enrolments of both sexes of Belize and Number of enrolments of both sexes of Qatar?
Offer a very short reply. -2.25e+04. In the year 2001, what is the difference between the Number of enrolments of both sexes in Belize and Number of enrolments of both sexes in Thailand?
Offer a very short reply. -4.05e+06. In the year 2001, what is the difference between the Number of enrolments of both sexes in Belize and Number of enrolments of both sexes in Uganda?
Your answer should be very brief. -5.46e+05. In the year 2001, what is the difference between the Number of enrolments of both sexes in Qatar and Number of enrolments of both sexes in Thailand?
Your answer should be compact. -4.03e+06. In the year 2001, what is the difference between the Number of enrolments of both sexes in Qatar and Number of enrolments of both sexes in Uganda?
Offer a terse response. -5.24e+05. In the year 2001, what is the difference between the Number of enrolments of both sexes of Thailand and Number of enrolments of both sexes of Uganda?
Ensure brevity in your answer.  3.50e+06. In the year 2004, what is the difference between the Number of enrolments of both sexes of Belize and Number of enrolments of both sexes of Qatar?
Ensure brevity in your answer.  -2.49e+04. In the year 2004, what is the difference between the Number of enrolments of both sexes of Belize and Number of enrolments of both sexes of Thailand?
Ensure brevity in your answer.  -4.22e+06. In the year 2004, what is the difference between the Number of enrolments of both sexes of Belize and Number of enrolments of both sexes of Uganda?
Provide a short and direct response. -7.04e+05. In the year 2004, what is the difference between the Number of enrolments of both sexes of Qatar and Number of enrolments of both sexes of Thailand?
Make the answer very short. -4.20e+06. In the year 2004, what is the difference between the Number of enrolments of both sexes of Qatar and Number of enrolments of both sexes of Uganda?
Provide a succinct answer. -6.79e+05. In the year 2004, what is the difference between the Number of enrolments of both sexes of Thailand and Number of enrolments of both sexes of Uganda?
Offer a terse response. 3.52e+06. In the year 2005, what is the difference between the Number of enrolments of both sexes in Belize and Number of enrolments of both sexes in Qatar?
Offer a terse response. -2.65e+04. In the year 2005, what is the difference between the Number of enrolments of both sexes in Belize and Number of enrolments of both sexes in Thailand?
Your answer should be compact. -4.50e+06. In the year 2005, what is the difference between the Number of enrolments of both sexes in Belize and Number of enrolments of both sexes in Uganda?
Ensure brevity in your answer.  -7.38e+05. In the year 2005, what is the difference between the Number of enrolments of both sexes of Qatar and Number of enrolments of both sexes of Thailand?
Give a very brief answer. -4.48e+06. In the year 2005, what is the difference between the Number of enrolments of both sexes of Qatar and Number of enrolments of both sexes of Uganda?
Your response must be concise. -7.12e+05. In the year 2005, what is the difference between the Number of enrolments of both sexes of Thailand and Number of enrolments of both sexes of Uganda?
Your answer should be compact. 3.77e+06. In the year 2006, what is the difference between the Number of enrolments of both sexes of Belize and Number of enrolments of both sexes of Qatar?
Give a very brief answer. -2.87e+04. In the year 2006, what is the difference between the Number of enrolments of both sexes in Belize and Number of enrolments of both sexes in Thailand?
Your answer should be very brief. -4.50e+06. In the year 2006, what is the difference between the Number of enrolments of both sexes of Belize and Number of enrolments of both sexes of Uganda?
Provide a succinct answer. -8.28e+05. In the year 2006, what is the difference between the Number of enrolments of both sexes in Qatar and Number of enrolments of both sexes in Thailand?
Keep it short and to the point. -4.47e+06. In the year 2006, what is the difference between the Number of enrolments of both sexes in Qatar and Number of enrolments of both sexes in Uganda?
Your answer should be very brief. -7.99e+05. In the year 2006, what is the difference between the Number of enrolments of both sexes in Thailand and Number of enrolments of both sexes in Uganda?
Your answer should be very brief. 3.67e+06. In the year 2007, what is the difference between the Number of enrolments of both sexes in Belize and Number of enrolments of both sexes in Qatar?
Provide a succinct answer. -3.06e+04. In the year 2007, what is the difference between the Number of enrolments of both sexes of Belize and Number of enrolments of both sexes of Thailand?
Offer a very short reply. -4.76e+06. In the year 2007, what is the difference between the Number of enrolments of both sexes in Belize and Number of enrolments of both sexes in Uganda?
Offer a very short reply. -1.00e+06. In the year 2007, what is the difference between the Number of enrolments of both sexes in Qatar and Number of enrolments of both sexes in Thailand?
Offer a terse response. -4.73e+06. In the year 2007, what is the difference between the Number of enrolments of both sexes in Qatar and Number of enrolments of both sexes in Uganda?
Offer a very short reply. -9.70e+05. In the year 2007, what is the difference between the Number of enrolments of both sexes of Thailand and Number of enrolments of both sexes of Uganda?
Offer a very short reply. 3.76e+06. In the year 2008, what is the difference between the Number of enrolments of both sexes of Belize and Number of enrolments of both sexes of Qatar?
Offer a terse response. -3.50e+04. In the year 2008, what is the difference between the Number of enrolments of both sexes in Belize and Number of enrolments of both sexes in Thailand?
Offer a very short reply. -4.70e+06. In the year 2008, what is the difference between the Number of enrolments of both sexes of Belize and Number of enrolments of both sexes of Uganda?
Keep it short and to the point. -1.11e+06. In the year 2008, what is the difference between the Number of enrolments of both sexes in Qatar and Number of enrolments of both sexes in Thailand?
Give a very brief answer. -4.66e+06. In the year 2008, what is the difference between the Number of enrolments of both sexes of Qatar and Number of enrolments of both sexes of Uganda?
Provide a short and direct response. -1.07e+06. In the year 2008, what is the difference between the Number of enrolments of both sexes in Thailand and Number of enrolments of both sexes in Uganda?
Your response must be concise. 3.59e+06. In the year 2009, what is the difference between the Number of enrolments of both sexes of Belize and Number of enrolments of both sexes of Qatar?
Your answer should be compact. -3.49e+04. In the year 2009, what is the difference between the Number of enrolments of both sexes of Belize and Number of enrolments of both sexes of Thailand?
Provide a short and direct response. -4.74e+06. In the year 2009, what is the difference between the Number of enrolments of both sexes of Belize and Number of enrolments of both sexes of Uganda?
Your answer should be very brief. -1.20e+06. In the year 2009, what is the difference between the Number of enrolments of both sexes in Qatar and Number of enrolments of both sexes in Thailand?
Make the answer very short. -4.70e+06. In the year 2009, what is the difference between the Number of enrolments of both sexes of Qatar and Number of enrolments of both sexes of Uganda?
Provide a succinct answer. -1.17e+06. In the year 2009, what is the difference between the Number of enrolments of both sexes in Thailand and Number of enrolments of both sexes in Uganda?
Keep it short and to the point. 3.54e+06. In the year 2010, what is the difference between the Number of enrolments of both sexes in Belize and Number of enrolments of both sexes in Qatar?
Keep it short and to the point. -3.61e+04. In the year 2010, what is the difference between the Number of enrolments of both sexes in Belize and Number of enrolments of both sexes in Thailand?
Make the answer very short. -4.77e+06. In the year 2010, what is the difference between the Number of enrolments of both sexes in Belize and Number of enrolments of both sexes in Uganda?
Provide a short and direct response. -1.23e+06. In the year 2010, what is the difference between the Number of enrolments of both sexes of Qatar and Number of enrolments of both sexes of Thailand?
Make the answer very short. -4.74e+06. In the year 2010, what is the difference between the Number of enrolments of both sexes of Qatar and Number of enrolments of both sexes of Uganda?
Keep it short and to the point. -1.20e+06. In the year 2010, what is the difference between the Number of enrolments of both sexes of Thailand and Number of enrolments of both sexes of Uganda?
Provide a short and direct response. 3.54e+06. What is the ratio of the Number of enrolments of both sexes in Belize in 2001 to that in 2004?
Your response must be concise. 0.84. What is the ratio of the Number of enrolments of both sexes in Qatar in 2001 to that in 2004?
Give a very brief answer. 0.87. What is the ratio of the Number of enrolments of both sexes in Thailand in 2001 to that in 2004?
Your response must be concise. 0.96. What is the ratio of the Number of enrolments of both sexes in Uganda in 2001 to that in 2004?
Your answer should be compact. 0.78. What is the ratio of the Number of enrolments of both sexes in Belize in 2001 to that in 2005?
Provide a short and direct response. 0.84. What is the ratio of the Number of enrolments of both sexes of Qatar in 2001 to that in 2005?
Your answer should be very brief. 0.84. What is the ratio of the Number of enrolments of both sexes in Thailand in 2001 to that in 2005?
Offer a terse response. 0.9. What is the ratio of the Number of enrolments of both sexes of Uganda in 2001 to that in 2005?
Ensure brevity in your answer.  0.74. What is the ratio of the Number of enrolments of both sexes in Belize in 2001 to that in 2006?
Ensure brevity in your answer.  0.81. What is the ratio of the Number of enrolments of both sexes in Qatar in 2001 to that in 2006?
Make the answer very short. 0.8. What is the ratio of the Number of enrolments of both sexes in Thailand in 2001 to that in 2006?
Offer a very short reply. 0.9. What is the ratio of the Number of enrolments of both sexes in Uganda in 2001 to that in 2006?
Your answer should be very brief. 0.67. What is the ratio of the Number of enrolments of both sexes of Belize in 2001 to that in 2007?
Provide a succinct answer. 0.8. What is the ratio of the Number of enrolments of both sexes in Qatar in 2001 to that in 2007?
Provide a succinct answer. 0.77. What is the ratio of the Number of enrolments of both sexes in Thailand in 2001 to that in 2007?
Your response must be concise. 0.85. What is the ratio of the Number of enrolments of both sexes in Uganda in 2001 to that in 2007?
Provide a short and direct response. 0.55. What is the ratio of the Number of enrolments of both sexes in Belize in 2001 to that in 2008?
Give a very brief answer. 0.78. What is the ratio of the Number of enrolments of both sexes of Qatar in 2001 to that in 2008?
Provide a short and direct response. 0.71. What is the ratio of the Number of enrolments of both sexes in Thailand in 2001 to that in 2008?
Offer a very short reply. 0.86. What is the ratio of the Number of enrolments of both sexes in Uganda in 2001 to that in 2008?
Make the answer very short. 0.5. What is the ratio of the Number of enrolments of both sexes of Belize in 2001 to that in 2009?
Your answer should be very brief. 0.77. What is the ratio of the Number of enrolments of both sexes of Qatar in 2001 to that in 2009?
Keep it short and to the point. 0.7. What is the ratio of the Number of enrolments of both sexes of Thailand in 2001 to that in 2009?
Provide a short and direct response. 0.85. What is the ratio of the Number of enrolments of both sexes of Uganda in 2001 to that in 2009?
Provide a succinct answer. 0.46. What is the ratio of the Number of enrolments of both sexes of Belize in 2001 to that in 2010?
Offer a very short reply. 0.74. What is the ratio of the Number of enrolments of both sexes in Qatar in 2001 to that in 2010?
Keep it short and to the point. 0.68. What is the ratio of the Number of enrolments of both sexes of Thailand in 2001 to that in 2010?
Make the answer very short. 0.85. What is the ratio of the Number of enrolments of both sexes of Uganda in 2001 to that in 2010?
Provide a short and direct response. 0.45. What is the ratio of the Number of enrolments of both sexes in Qatar in 2004 to that in 2005?
Offer a terse response. 0.97. What is the ratio of the Number of enrolments of both sexes in Thailand in 2004 to that in 2005?
Give a very brief answer. 0.94. What is the ratio of the Number of enrolments of both sexes of Uganda in 2004 to that in 2005?
Ensure brevity in your answer.  0.96. What is the ratio of the Number of enrolments of both sexes of Belize in 2004 to that in 2006?
Provide a short and direct response. 0.97. What is the ratio of the Number of enrolments of both sexes of Qatar in 2004 to that in 2006?
Provide a succinct answer. 0.92. What is the ratio of the Number of enrolments of both sexes in Thailand in 2004 to that in 2006?
Your answer should be very brief. 0.94. What is the ratio of the Number of enrolments of both sexes in Uganda in 2004 to that in 2006?
Provide a succinct answer. 0.85. What is the ratio of the Number of enrolments of both sexes of Belize in 2004 to that in 2007?
Your answer should be very brief. 0.95. What is the ratio of the Number of enrolments of both sexes of Qatar in 2004 to that in 2007?
Provide a short and direct response. 0.88. What is the ratio of the Number of enrolments of both sexes in Thailand in 2004 to that in 2007?
Keep it short and to the point. 0.89. What is the ratio of the Number of enrolments of both sexes of Uganda in 2004 to that in 2007?
Offer a very short reply. 0.71. What is the ratio of the Number of enrolments of both sexes in Belize in 2004 to that in 2008?
Give a very brief answer. 0.93. What is the ratio of the Number of enrolments of both sexes in Qatar in 2004 to that in 2008?
Your answer should be compact. 0.82. What is the ratio of the Number of enrolments of both sexes in Thailand in 2004 to that in 2008?
Ensure brevity in your answer.  0.9. What is the ratio of the Number of enrolments of both sexes in Uganda in 2004 to that in 2008?
Your response must be concise. 0.64. What is the ratio of the Number of enrolments of both sexes of Belize in 2004 to that in 2009?
Give a very brief answer. 0.92. What is the ratio of the Number of enrolments of both sexes of Qatar in 2004 to that in 2009?
Keep it short and to the point. 0.81. What is the ratio of the Number of enrolments of both sexes in Thailand in 2004 to that in 2009?
Offer a terse response. 0.89. What is the ratio of the Number of enrolments of both sexes in Uganda in 2004 to that in 2009?
Your response must be concise. 0.59. What is the ratio of the Number of enrolments of both sexes of Belize in 2004 to that in 2010?
Make the answer very short. 0.89. What is the ratio of the Number of enrolments of both sexes of Qatar in 2004 to that in 2010?
Provide a short and direct response. 0.78. What is the ratio of the Number of enrolments of both sexes in Thailand in 2004 to that in 2010?
Make the answer very short. 0.88. What is the ratio of the Number of enrolments of both sexes of Uganda in 2004 to that in 2010?
Your answer should be compact. 0.58. What is the ratio of the Number of enrolments of both sexes in Belize in 2005 to that in 2006?
Your answer should be very brief. 0.97. What is the ratio of the Number of enrolments of both sexes of Qatar in 2005 to that in 2006?
Your answer should be very brief. 0.95. What is the ratio of the Number of enrolments of both sexes in Thailand in 2005 to that in 2006?
Your answer should be compact. 1. What is the ratio of the Number of enrolments of both sexes of Uganda in 2005 to that in 2006?
Your answer should be very brief. 0.89. What is the ratio of the Number of enrolments of both sexes in Belize in 2005 to that in 2007?
Your response must be concise. 0.96. What is the ratio of the Number of enrolments of both sexes of Qatar in 2005 to that in 2007?
Give a very brief answer. 0.91. What is the ratio of the Number of enrolments of both sexes in Thailand in 2005 to that in 2007?
Your answer should be compact. 0.95. What is the ratio of the Number of enrolments of both sexes in Uganda in 2005 to that in 2007?
Offer a very short reply. 0.74. What is the ratio of the Number of enrolments of both sexes of Belize in 2005 to that in 2008?
Give a very brief answer. 0.94. What is the ratio of the Number of enrolments of both sexes of Qatar in 2005 to that in 2008?
Provide a short and direct response. 0.84. What is the ratio of the Number of enrolments of both sexes of Thailand in 2005 to that in 2008?
Your response must be concise. 0.96. What is the ratio of the Number of enrolments of both sexes of Uganda in 2005 to that in 2008?
Ensure brevity in your answer.  0.67. What is the ratio of the Number of enrolments of both sexes in Belize in 2005 to that in 2009?
Provide a succinct answer. 0.92. What is the ratio of the Number of enrolments of both sexes of Qatar in 2005 to that in 2009?
Give a very brief answer. 0.84. What is the ratio of the Number of enrolments of both sexes of Thailand in 2005 to that in 2009?
Keep it short and to the point. 0.95. What is the ratio of the Number of enrolments of both sexes of Uganda in 2005 to that in 2009?
Your answer should be compact. 0.62. What is the ratio of the Number of enrolments of both sexes in Belize in 2005 to that in 2010?
Offer a very short reply. 0.89. What is the ratio of the Number of enrolments of both sexes of Qatar in 2005 to that in 2010?
Make the answer very short. 0.81. What is the ratio of the Number of enrolments of both sexes in Thailand in 2005 to that in 2010?
Offer a terse response. 0.94. What is the ratio of the Number of enrolments of both sexes in Uganda in 2005 to that in 2010?
Your answer should be compact. 0.61. What is the ratio of the Number of enrolments of both sexes in Belize in 2006 to that in 2007?
Your answer should be compact. 0.99. What is the ratio of the Number of enrolments of both sexes in Qatar in 2006 to that in 2007?
Provide a succinct answer. 0.96. What is the ratio of the Number of enrolments of both sexes of Thailand in 2006 to that in 2007?
Make the answer very short. 0.95. What is the ratio of the Number of enrolments of both sexes in Uganda in 2006 to that in 2007?
Offer a terse response. 0.83. What is the ratio of the Number of enrolments of both sexes in Belize in 2006 to that in 2008?
Provide a succinct answer. 0.97. What is the ratio of the Number of enrolments of both sexes of Qatar in 2006 to that in 2008?
Keep it short and to the point. 0.89. What is the ratio of the Number of enrolments of both sexes in Thailand in 2006 to that in 2008?
Your answer should be compact. 0.96. What is the ratio of the Number of enrolments of both sexes in Uganda in 2006 to that in 2008?
Your response must be concise. 0.75. What is the ratio of the Number of enrolments of both sexes in Belize in 2006 to that in 2009?
Keep it short and to the point. 0.95. What is the ratio of the Number of enrolments of both sexes of Qatar in 2006 to that in 2009?
Offer a very short reply. 0.88. What is the ratio of the Number of enrolments of both sexes of Thailand in 2006 to that in 2009?
Provide a short and direct response. 0.95. What is the ratio of the Number of enrolments of both sexes in Uganda in 2006 to that in 2009?
Offer a terse response. 0.7. What is the ratio of the Number of enrolments of both sexes in Belize in 2006 to that in 2010?
Provide a short and direct response. 0.92. What is the ratio of the Number of enrolments of both sexes in Qatar in 2006 to that in 2010?
Your response must be concise. 0.85. What is the ratio of the Number of enrolments of both sexes of Thailand in 2006 to that in 2010?
Offer a very short reply. 0.94. What is the ratio of the Number of enrolments of both sexes in Uganda in 2006 to that in 2010?
Offer a very short reply. 0.68. What is the ratio of the Number of enrolments of both sexes in Belize in 2007 to that in 2008?
Your answer should be compact. 0.98. What is the ratio of the Number of enrolments of both sexes of Qatar in 2007 to that in 2008?
Offer a terse response. 0.92. What is the ratio of the Number of enrolments of both sexes in Thailand in 2007 to that in 2008?
Make the answer very short. 1.01. What is the ratio of the Number of enrolments of both sexes in Uganda in 2007 to that in 2008?
Offer a terse response. 0.91. What is the ratio of the Number of enrolments of both sexes of Belize in 2007 to that in 2009?
Offer a terse response. 0.96. What is the ratio of the Number of enrolments of both sexes in Qatar in 2007 to that in 2009?
Ensure brevity in your answer.  0.92. What is the ratio of the Number of enrolments of both sexes of Uganda in 2007 to that in 2009?
Provide a succinct answer. 0.84. What is the ratio of the Number of enrolments of both sexes in Belize in 2007 to that in 2010?
Keep it short and to the point. 0.93. What is the ratio of the Number of enrolments of both sexes in Qatar in 2007 to that in 2010?
Your response must be concise. 0.89. What is the ratio of the Number of enrolments of both sexes in Thailand in 2007 to that in 2010?
Your response must be concise. 1. What is the ratio of the Number of enrolments of both sexes of Uganda in 2007 to that in 2010?
Offer a very short reply. 0.82. What is the ratio of the Number of enrolments of both sexes of Belize in 2008 to that in 2009?
Offer a very short reply. 0.98. What is the ratio of the Number of enrolments of both sexes of Qatar in 2008 to that in 2009?
Give a very brief answer. 0.99. What is the ratio of the Number of enrolments of both sexes of Thailand in 2008 to that in 2009?
Provide a succinct answer. 0.99. What is the ratio of the Number of enrolments of both sexes in Uganda in 2008 to that in 2009?
Provide a short and direct response. 0.92. What is the ratio of the Number of enrolments of both sexes in Belize in 2008 to that in 2010?
Provide a short and direct response. 0.95. What is the ratio of the Number of enrolments of both sexes of Qatar in 2008 to that in 2010?
Provide a short and direct response. 0.96. What is the ratio of the Number of enrolments of both sexes of Thailand in 2008 to that in 2010?
Ensure brevity in your answer.  0.98. What is the ratio of the Number of enrolments of both sexes of Uganda in 2008 to that in 2010?
Your response must be concise. 0.9. What is the ratio of the Number of enrolments of both sexes of Belize in 2009 to that in 2010?
Offer a very short reply. 0.97. What is the ratio of the Number of enrolments of both sexes of Qatar in 2009 to that in 2010?
Make the answer very short. 0.97. What is the ratio of the Number of enrolments of both sexes in Thailand in 2009 to that in 2010?
Offer a terse response. 0.99. What is the ratio of the Number of enrolments of both sexes of Uganda in 2009 to that in 2010?
Your response must be concise. 0.98. What is the difference between the highest and the second highest Number of enrolments of both sexes in Belize?
Your response must be concise. 1059. What is the difference between the highest and the second highest Number of enrolments of both sexes of Qatar?
Make the answer very short. 2340. What is the difference between the highest and the second highest Number of enrolments of both sexes in Thailand?
Your response must be concise. 1.78e+04. What is the difference between the highest and the second highest Number of enrolments of both sexes of Uganda?
Your answer should be compact. 3.16e+04. What is the difference between the highest and the lowest Number of enrolments of both sexes of Belize?
Ensure brevity in your answer.  8385. What is the difference between the highest and the lowest Number of enrolments of both sexes in Qatar?
Offer a very short reply. 2.20e+04. What is the difference between the highest and the lowest Number of enrolments of both sexes in Thailand?
Your answer should be compact. 7.35e+05. What is the difference between the highest and the lowest Number of enrolments of both sexes of Uganda?
Keep it short and to the point. 6.94e+05. 